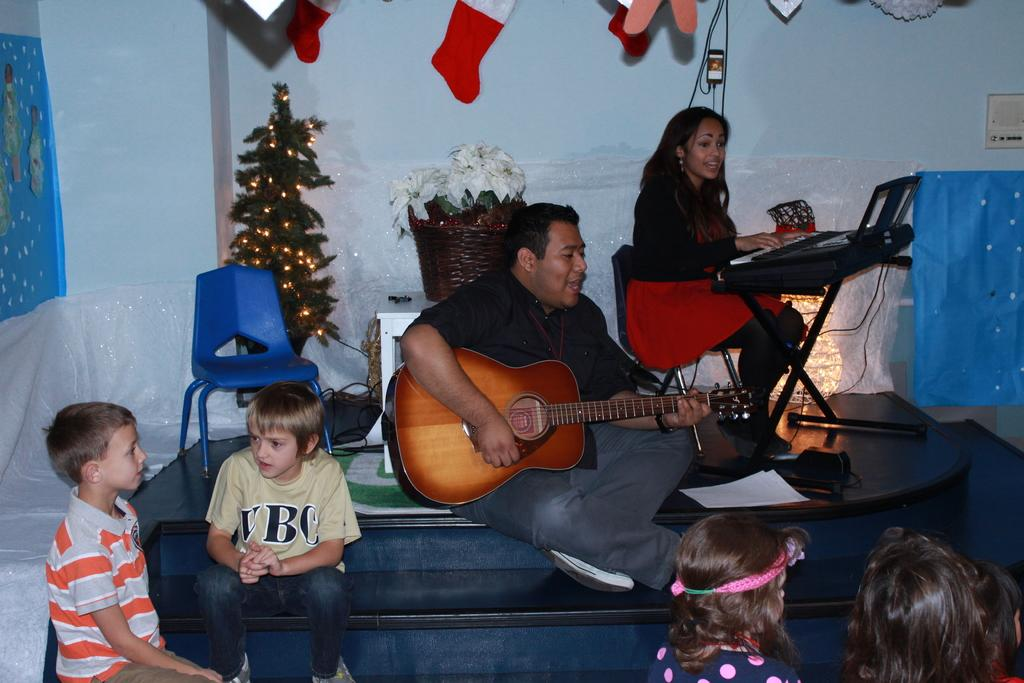What is the man doing in the image? The man is playing a guitar. What is the woman doing in the image? The woman is playing a piano. How many children are seated in the image? There are two boys and two girls seated in the image. What is a festive decoration present in the image? There is a Christmas tree in the image. What type of furniture can be seen in the image? There is a chair in the image. What color is the coat worn by the woman playing the piano? There is no mention of a coat in the image, as the woman is playing the piano without one. Is there any blood visible in the image? No, there is no blood visible in the image. 